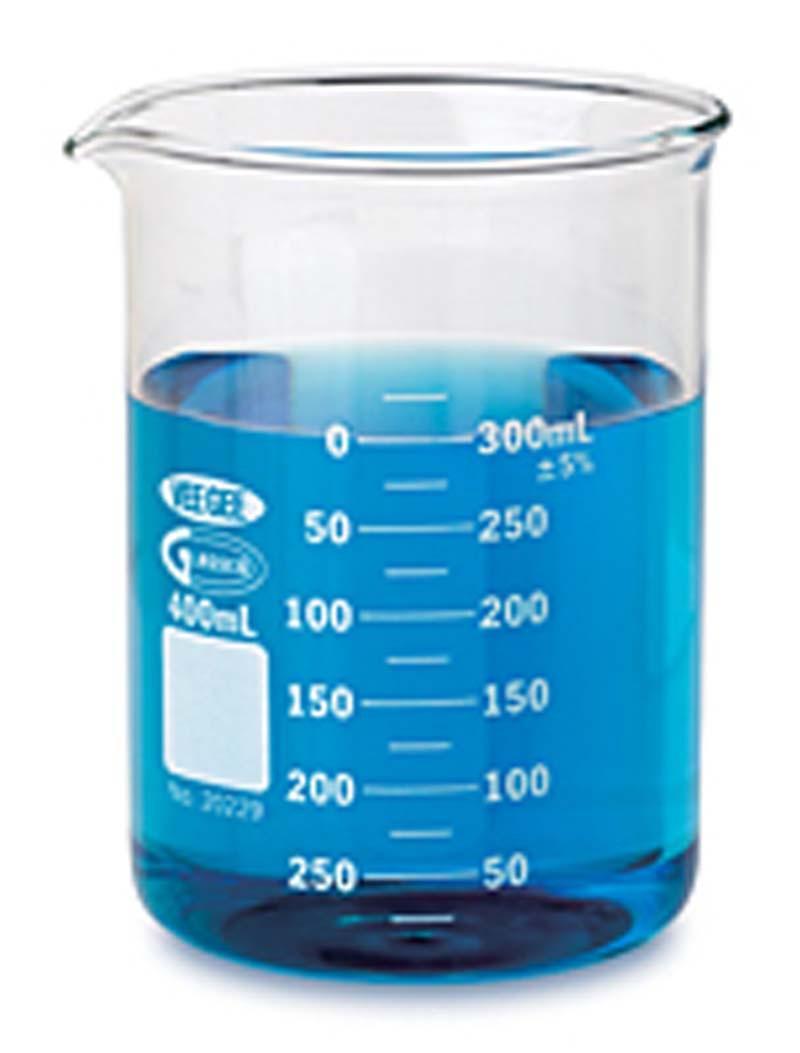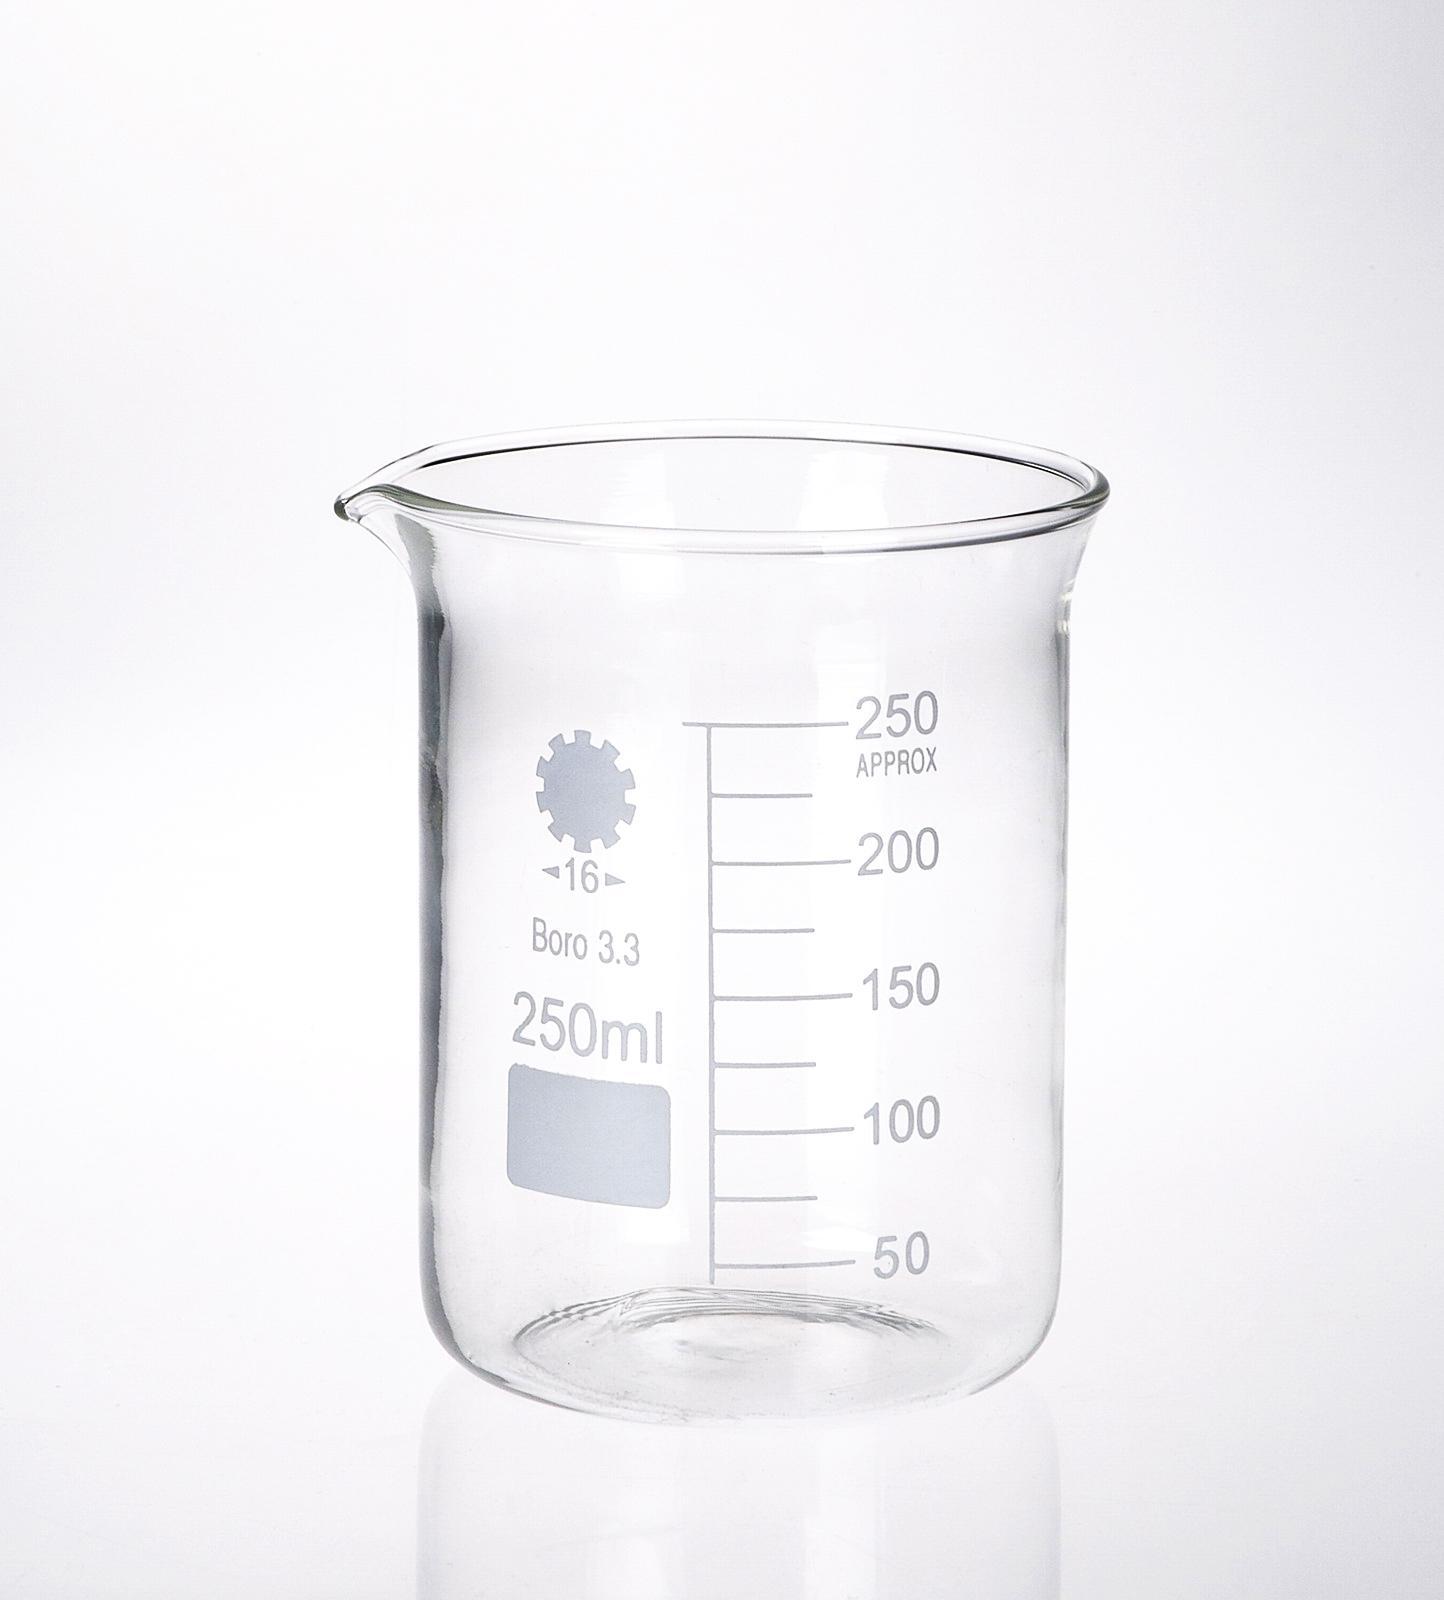The first image is the image on the left, the second image is the image on the right. Assess this claim about the two images: "Right image contains a single empty glass vessel shaped like a cylinder with a small pour spout on one side.". Correct or not? Answer yes or no. Yes. The first image is the image on the left, the second image is the image on the right. Assess this claim about the two images: "There are two flasks in the pair of images.". Correct or not? Answer yes or no. Yes. 